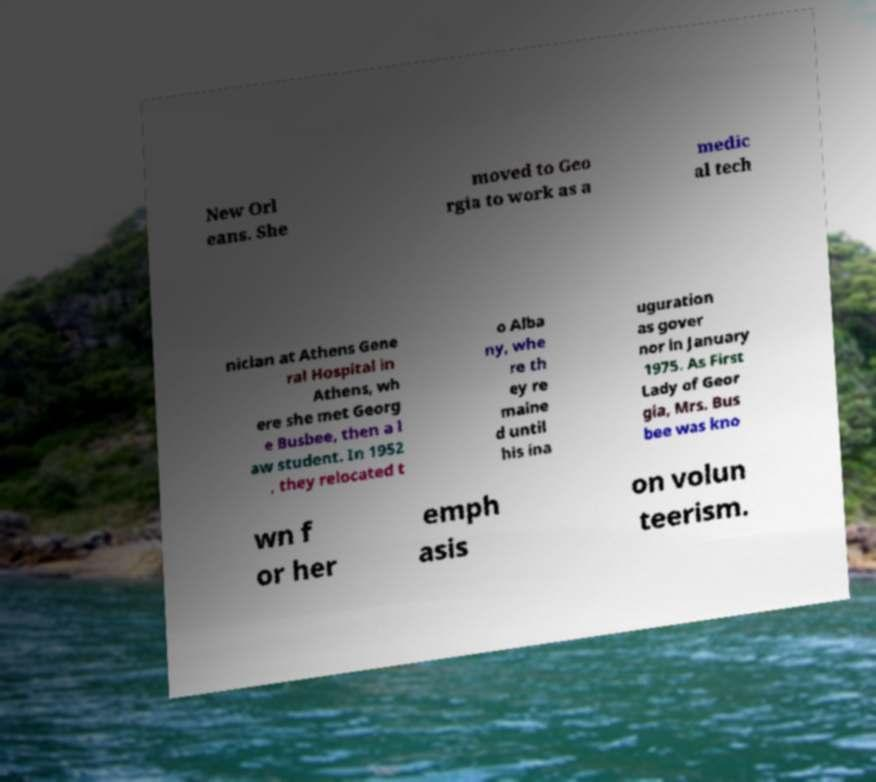Can you accurately transcribe the text from the provided image for me? New Orl eans. She moved to Geo rgia to work as a medic al tech nician at Athens Gene ral Hospital in Athens, wh ere she met Georg e Busbee, then a l aw student. In 1952 , they relocated t o Alba ny, whe re th ey re maine d until his ina uguration as gover nor in January 1975. As First Lady of Geor gia, Mrs. Bus bee was kno wn f or her emph asis on volun teerism. 